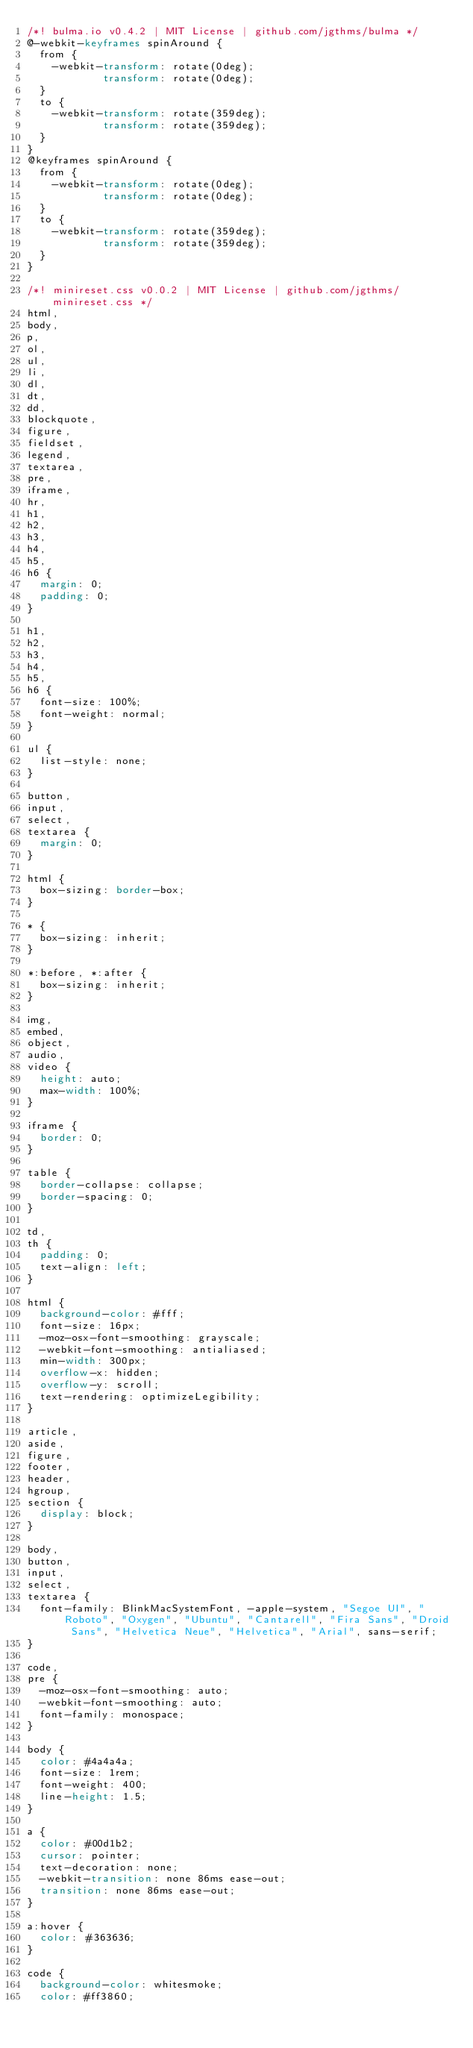Convert code to text. <code><loc_0><loc_0><loc_500><loc_500><_CSS_>/*! bulma.io v0.4.2 | MIT License | github.com/jgthms/bulma */
@-webkit-keyframes spinAround {
  from {
    -webkit-transform: rotate(0deg);
            transform: rotate(0deg);
  }
  to {
    -webkit-transform: rotate(359deg);
            transform: rotate(359deg);
  }
}
@keyframes spinAround {
  from {
    -webkit-transform: rotate(0deg);
            transform: rotate(0deg);
  }
  to {
    -webkit-transform: rotate(359deg);
            transform: rotate(359deg);
  }
}

/*! minireset.css v0.0.2 | MIT License | github.com/jgthms/minireset.css */
html,
body,
p,
ol,
ul,
li,
dl,
dt,
dd,
blockquote,
figure,
fieldset,
legend,
textarea,
pre,
iframe,
hr,
h1,
h2,
h3,
h4,
h5,
h6 {
  margin: 0;
  padding: 0;
}

h1,
h2,
h3,
h4,
h5,
h6 {
  font-size: 100%;
  font-weight: normal;
}

ul {
  list-style: none;
}

button,
input,
select,
textarea {
  margin: 0;
}

html {
  box-sizing: border-box;
}

* {
  box-sizing: inherit;
}

*:before, *:after {
  box-sizing: inherit;
}

img,
embed,
object,
audio,
video {
  height: auto;
  max-width: 100%;
}

iframe {
  border: 0;
}

table {
  border-collapse: collapse;
  border-spacing: 0;
}

td,
th {
  padding: 0;
  text-align: left;
}

html {
  background-color: #fff;
  font-size: 16px;
  -moz-osx-font-smoothing: grayscale;
  -webkit-font-smoothing: antialiased;
  min-width: 300px;
  overflow-x: hidden;
  overflow-y: scroll;
  text-rendering: optimizeLegibility;
}

article,
aside,
figure,
footer,
header,
hgroup,
section {
  display: block;
}

body,
button,
input,
select,
textarea {
  font-family: BlinkMacSystemFont, -apple-system, "Segoe UI", "Roboto", "Oxygen", "Ubuntu", "Cantarell", "Fira Sans", "Droid Sans", "Helvetica Neue", "Helvetica", "Arial", sans-serif;
}

code,
pre {
  -moz-osx-font-smoothing: auto;
  -webkit-font-smoothing: auto;
  font-family: monospace;
}

body {
  color: #4a4a4a;
  font-size: 1rem;
  font-weight: 400;
  line-height: 1.5;
}

a {
  color: #00d1b2;
  cursor: pointer;
  text-decoration: none;
  -webkit-transition: none 86ms ease-out;
  transition: none 86ms ease-out;
}

a:hover {
  color: #363636;
}

code {
  background-color: whitesmoke;
  color: #ff3860;</code> 